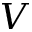<formula> <loc_0><loc_0><loc_500><loc_500>V</formula> 